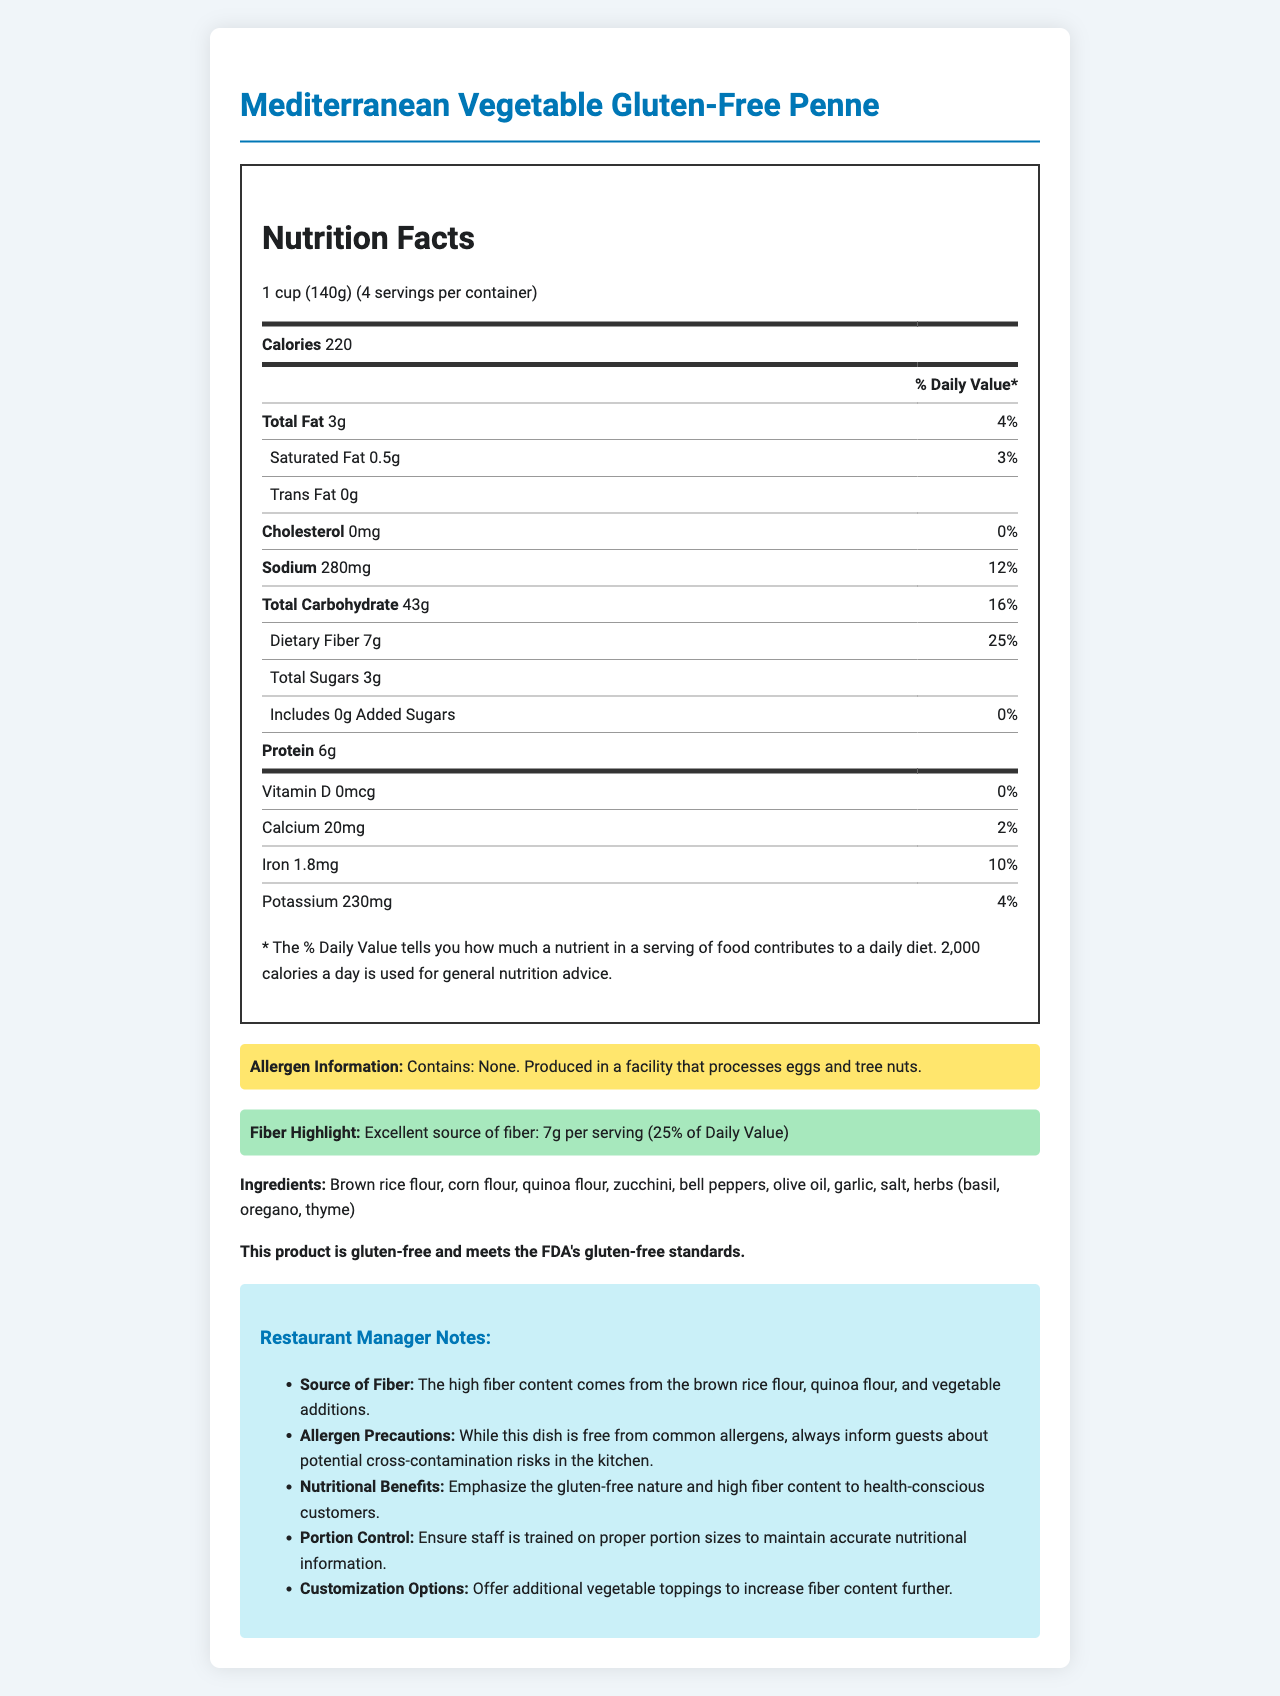What is the serving size for the Mediterranean Vegetable Gluten-Free Penne? The serving size is listed first in the Nutrition Facts section as "1 cup (140g)".
Answer: 1 cup (140g) How many grams of dietary fiber are in each serving? The dietary fiber content per serving is listed in the Nutrition Facts label under "Dietary Fiber" as 7g.
Answer: 7g What percentage of the Daily Value is the sodium content per serving? The percentage of daily value for sodium is shown next to the sodium content in the Nutrition Facts: "12%".
Answer: 12% What are the main sources of fiber in this dish? The Restaurant Manager Notes section specifies that the high fiber content comes from these ingredients.
Answer: Brown rice flour, quinoa flour, and vegetable additions Is this pasta dish gluten-free? The document clearly states that the product is gluten-free and meets the FDA's gluten-free standards.
Answer: Yes Which of the following is NOT an ingredient in this pasta dish?
A. Zucchini
B. Almond flour
C. Olive oil The ingredients listed in the document are brown rice flour, corn flour, quinoa flour, zucchini, bell peppers, olive oil, garlic, salt, and herbs.
Answer: B. Almond flour How many calories are there per serving of this pasta dish? The calories per serving are listed in the Nutrition Facts section as "220 calories".
Answer: 220 Does the Mediterranean Vegetable Gluten-Free Penne contain any trans fat? The Nutrition Facts label indicates that the trans fat content is "0g".
Answer: No Which nutrient has the highest percentage of Daily Value in this dish?
I. Calcium
II. Dietary Fiber
III. Iron The percentage of Daily Value for Dietary Fiber is 25%, which is the highest among the listed options.
Answer: II. Dietary Fiber Does the document provide information about the production facility's allergen processing? The allergen information section notes that the product is produced in a facility that processes eggs and tree nuts.
Answer: Yes How many servings are there per container? The servings per container are listed in the Nutrition Facts section as "4".
Answer: 4 What is the main nutritional benefit emphasized for this pasta dish? The restaurant manager notes emphasize the gluten-free nature and high fiber content as nutritional benefits.
Answer: High fiber content What is the total amount of sugars per serving? The total sugars per serving is listed under "Total Sugars" in the Nutrition Facts section.
Answer: 3g Can you determine the exact potassium percentage in the recommended daily diet from this document? The document states the potassium content and its daily value percentage but does not specify the total recommended daily amount of potassium.
Answer: No Summarize the main features of the Mediterranean Vegetable Gluten-Free Penne. The document outlines the nutritional content, ingredients, and allergen information of the product. It highlights the gluten-free nature and the source of fiber, provides notes for restaurant managers, and details the servings per container and calories per serving.
Answer: The Mediterranean Vegetable Gluten-Free Penne is a gluten-free pasta dish with excellent fiber content. Each serving (1 cup, 140g) provides 220 calories, 3g of total fat, 280mg sodium, 43g total carbohydrates, 7g dietary fiber, 3g total sugars, and 6g protein. It is free of cholesterol and trans fat. The dish contains brown rice flour, corn flour, quinoa flour, and various vegetables, and is produced in a facility that processes eggs and tree nuts. It is emphasized for its high fiber content and suitability for health-conscious customers. 